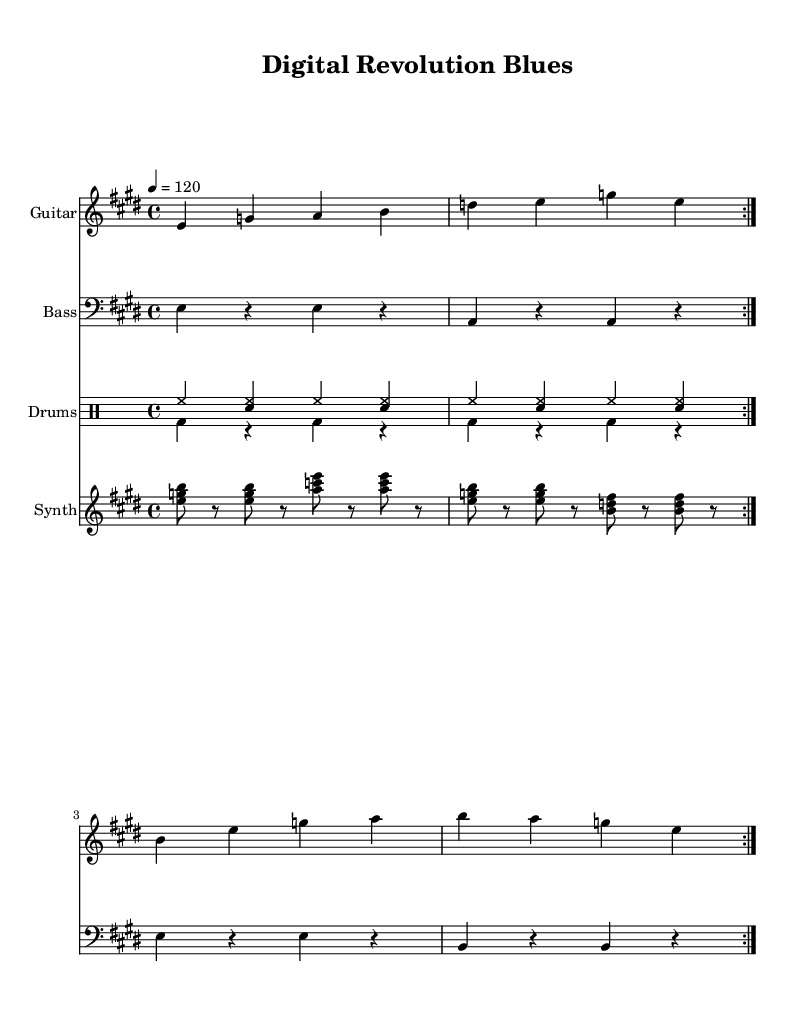What is the key signature of this music? The key signature is E major, which has four sharps (F#, C#, G#, D#). This can be determined from the beginning of the score where the key signature is indicated.
Answer: E major What is the time signature of the piece? The time signature, located after the key signature, shows that this piece is in 4/4 time, indicating four beats per measure.
Answer: 4/4 What is the tempo marking? The tempo marking is indicated at the start of the music with a metronome marking of 120 beats per minute. It tells performers the speed at which to play the piece.
Answer: 120 How many measures are repeated in the guitar part? The guitar part indicates a repeat section (shown as "volta") that occurs twice, meaning the measures that follow are played two times in total.
Answer: 2 What is the instrument suggested for the rhythm section? The rhythm section consists of drums, which are indicated by the use of a "DrumStaff" in the score, suggesting the use of percussion instruments.
Answer: Drums What characterizes the music style of this piece? The music style reflects influences from blues rock, as indicated by the use of common blues chord patterns and lyrical themes regarding digital technology and societal change, typical of blues music.
Answer: Blues rock What type of chord progressions are likely used in this composition? Based on the blues genre structure, this music likely uses common chord progressions such as the I-IV-V progression, prevalent in blues, although specific chords are not shown directly in the sheet music.
Answer: I-IV-V 